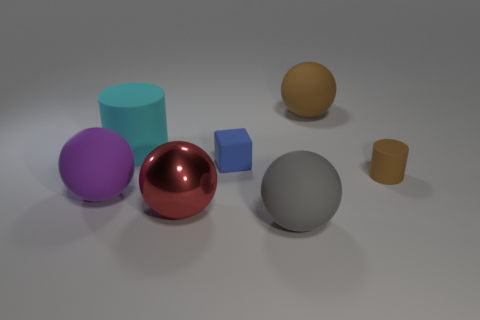Is there any particular lighting or mood established by the scene? The scene is lit by a soft, diffuse light source, giving it a calm and neutral atmosphere. The shadows cast by the objects are soft and not too pronounced, which suggests an ambient lighting environment, often used to showcase objects clearly without dramatic effects. 